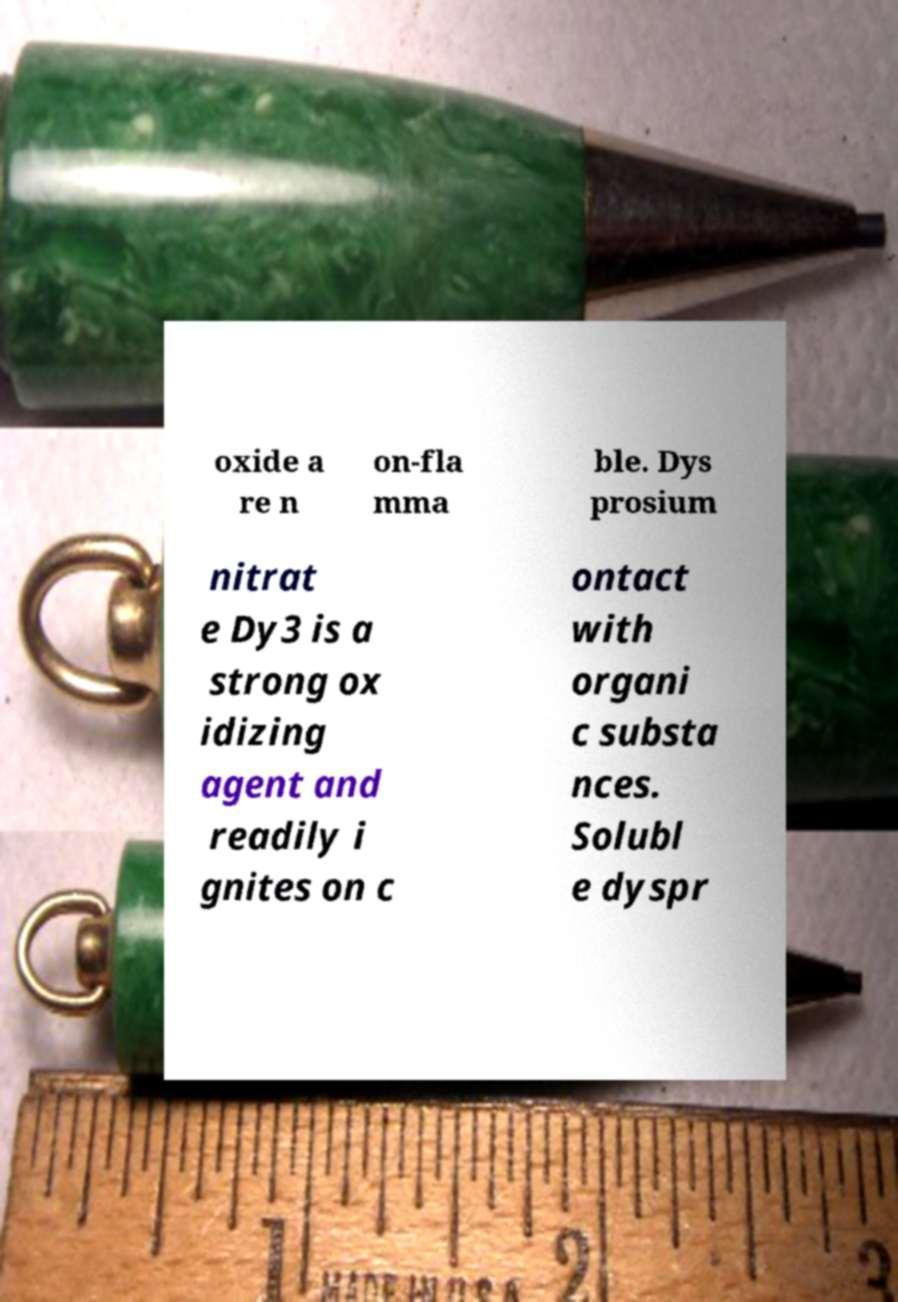What messages or text are displayed in this image? I need them in a readable, typed format. oxide a re n on-fla mma ble. Dys prosium nitrat e Dy3 is a strong ox idizing agent and readily i gnites on c ontact with organi c substa nces. Solubl e dyspr 